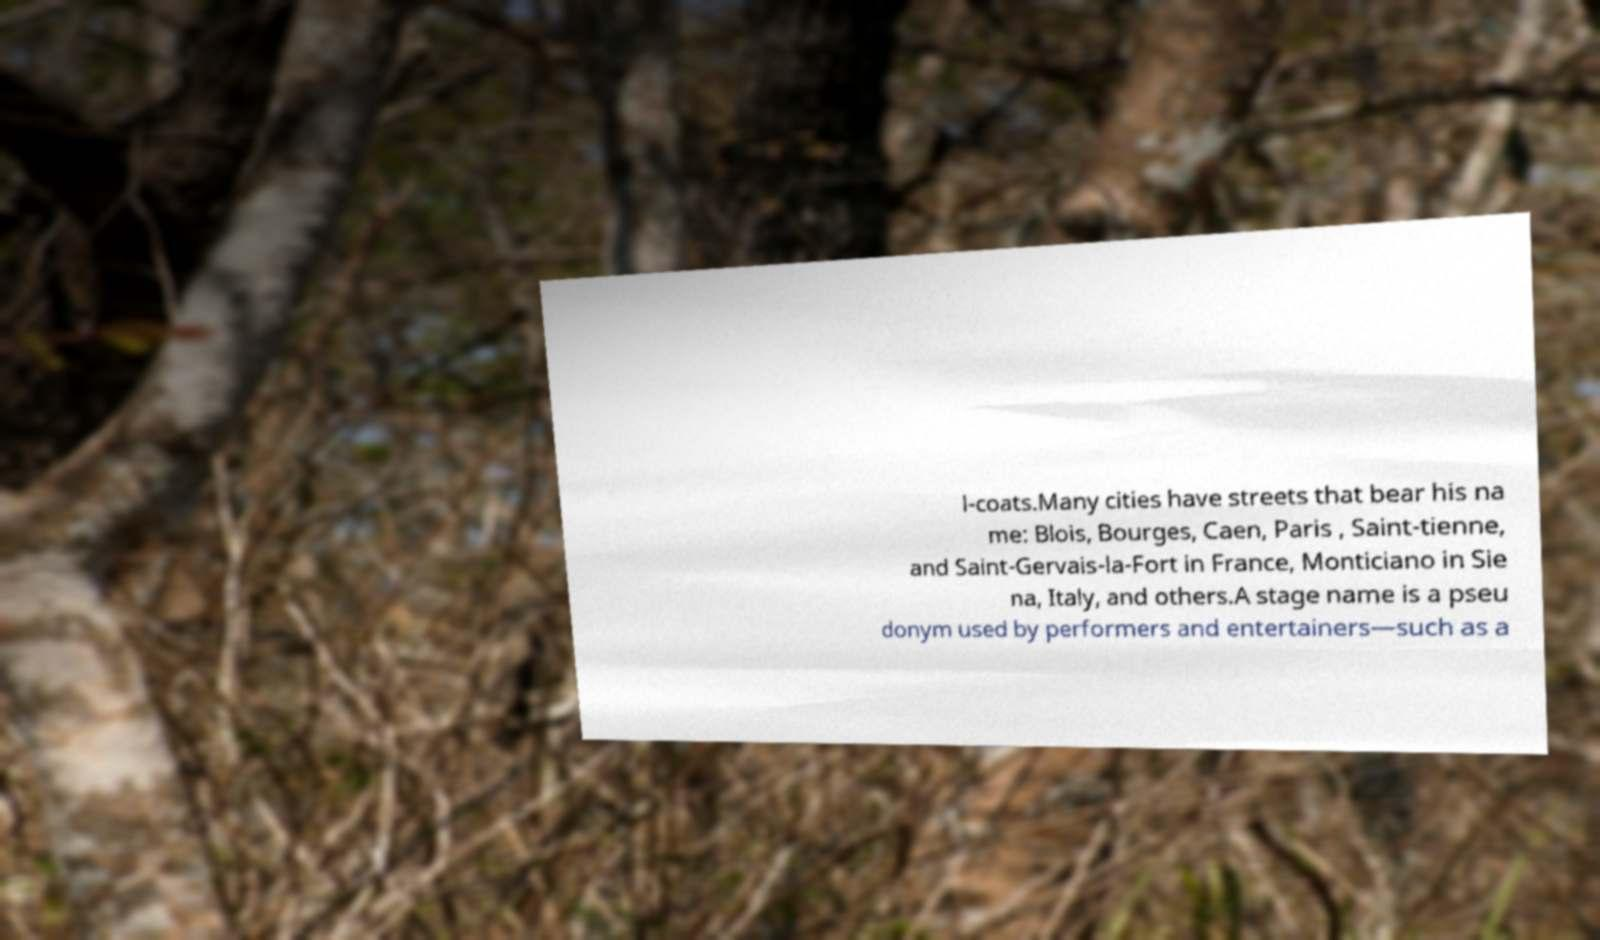Please read and relay the text visible in this image. What does it say? l-coats.Many cities have streets that bear his na me: Blois, Bourges, Caen, Paris , Saint-tienne, and Saint-Gervais-la-Fort in France, Monticiano in Sie na, Italy, and others.A stage name is a pseu donym used by performers and entertainers—such as a 